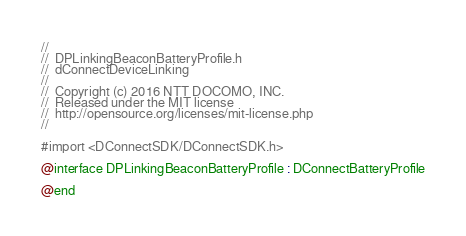<code> <loc_0><loc_0><loc_500><loc_500><_C_>//
//  DPLinkingBeaconBatteryProfile.h
//  dConnectDeviceLinking
//
//  Copyright (c) 2016 NTT DOCOMO, INC.
//  Released under the MIT license
//  http://opensource.org/licenses/mit-license.php
//

#import <DConnectSDK/DConnectSDK.h>

@interface DPLinkingBeaconBatteryProfile : DConnectBatteryProfile

@end
</code> 